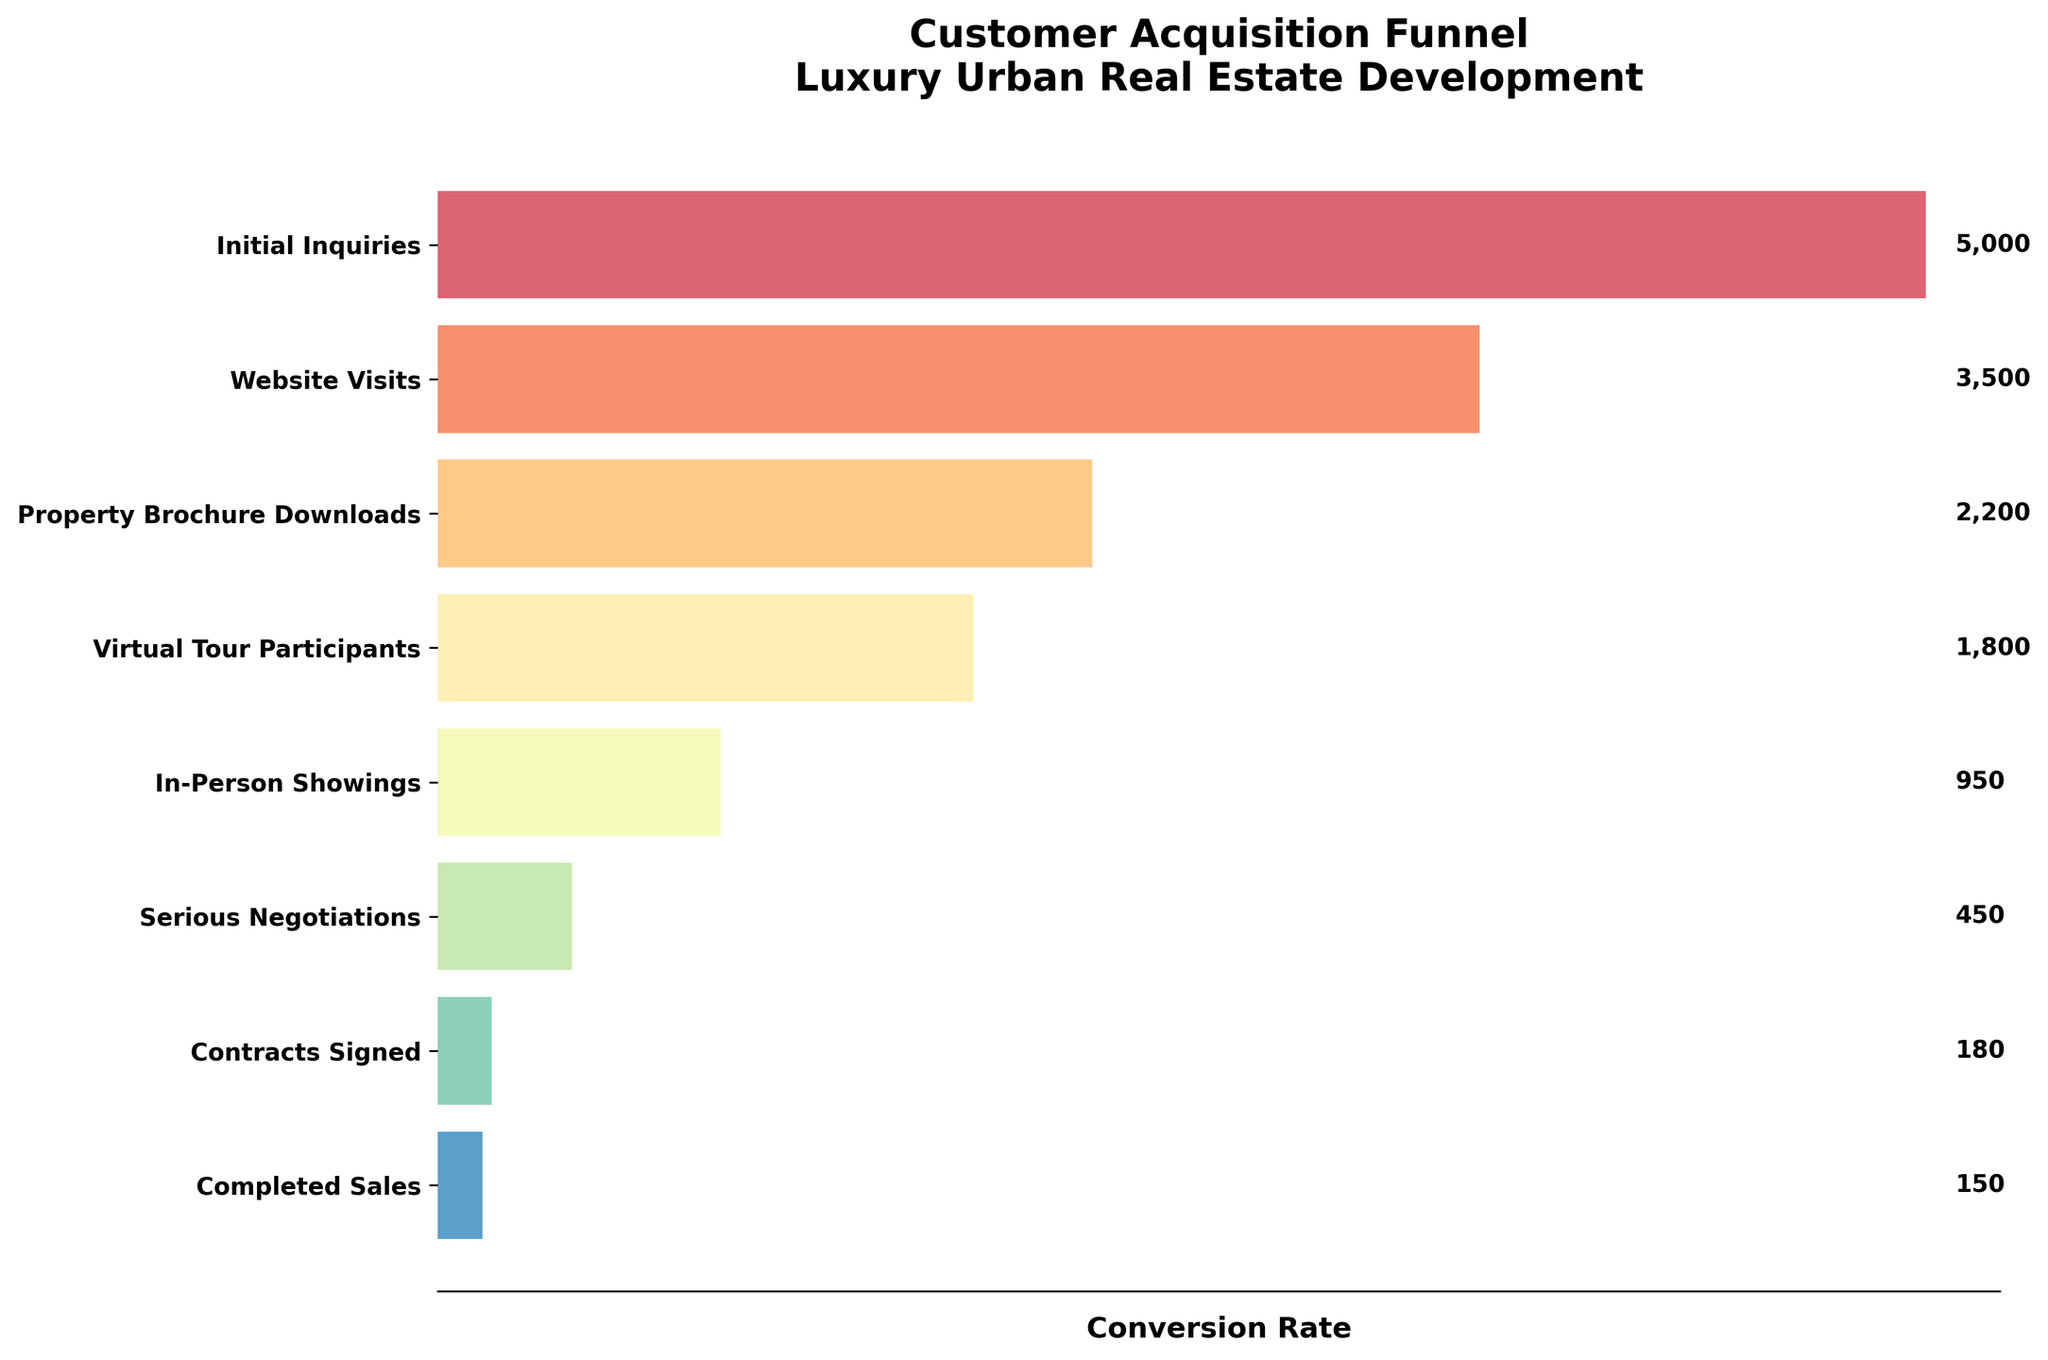What's the title of this figure? The title of the figure is always prominently displayed at the top. It is often bold and larger in font size compared to other text elements.
Answer: Customer Acquisition Funnel - Luxury Urban Real Estate Development How many stages are shown in the funnel chart? To determine the number of stages, count each unique horizontal bar in the funnel chart from top to bottom.
Answer: 8 Which stage has the highest number of prospects? Identify the stage with the longest horizontal bar, as this represents the highest number of prospects.
Answer: Initial Inquiries How many prospects downloaded the property brochure? Locate the bar corresponding to the "Property Brochure Downloads" stage; the number of prospects is usually written next to the bar or can be visually estimated from its length.
Answer: 2200 What's the difference in the number of prospects between Virtual Tour Participants and In-Person Showings? Find the bars for both "Virtual Tour Participants" and "In-Person Showings", note their prospect numbers, and subtract the smaller number from the larger one.
Answer: 850 What percentage of the Initial Inquiries progressed to Completed Sales? To calculate this, divide the number of Completed Sales by the number of Initial Inquiries and multiply by 100: (150/5000) * 100.
Answer: 3% Which stage shows the biggest drop in prospects compared to the previous stage? Look for the steepest drop between consecutive bars by comparing the widths and finding the pair with the largest numerical difference.
Answer: In-Person Showings to Serious Negotiations How many stages had fewer than 1000 prospects? Count the number of stages where the identified number of prospects is less than 1000.
Answer: 4 Is the number of Completed Sales greater than the number of Serious Negotiations? Compare the numbers associated with the "Completed Sales" and "Serious Negotiations" bars.
Answer: No What is the conversion rate from Virtual Tour Participants to In-Person Showings? Conversion rate is calculated as (In-Person Showings / Virtual Tour Participants) * 100: (950/1800) * 100.
Answer: 52.78% 